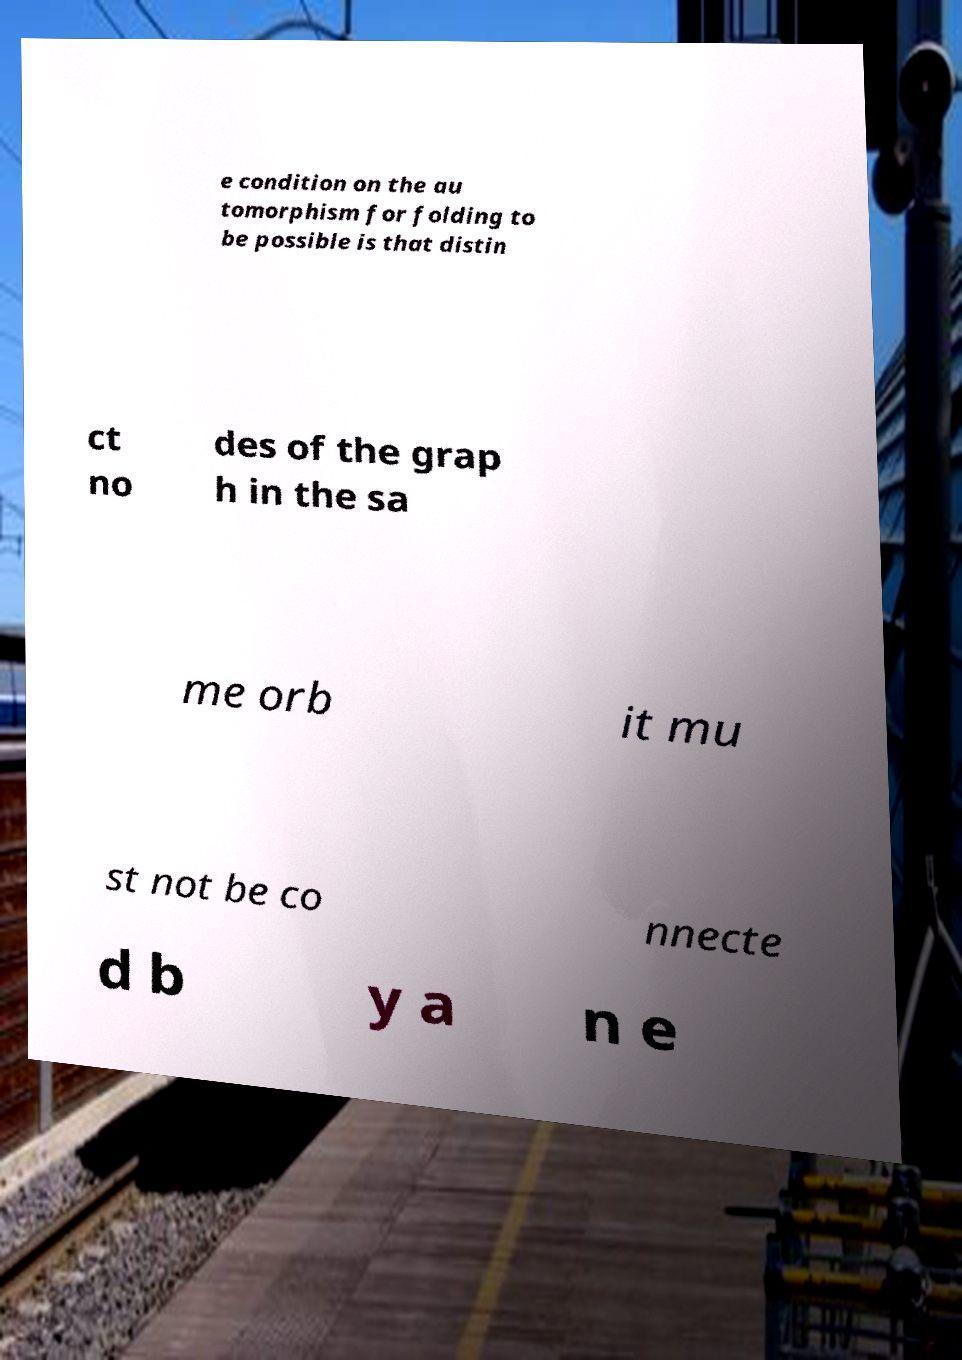Can you accurately transcribe the text from the provided image for me? e condition on the au tomorphism for folding to be possible is that distin ct no des of the grap h in the sa me orb it mu st not be co nnecte d b y a n e 